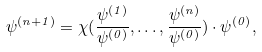Convert formula to latex. <formula><loc_0><loc_0><loc_500><loc_500>\psi ^ { ( n + 1 ) } = \chi ( \frac { \psi ^ { ( 1 ) } } { \psi ^ { ( 0 ) } } , \dots , \frac { \psi ^ { ( n ) } } { \psi ^ { ( 0 ) } } ) \cdot \psi ^ { ( 0 ) } ,</formula> 